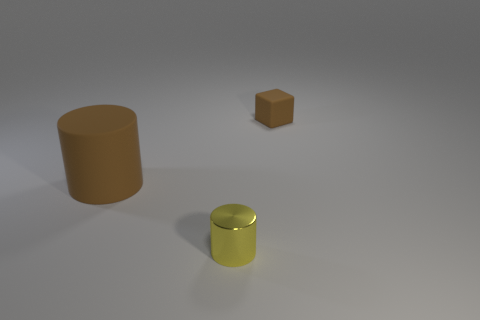Add 1 cyan balls. How many objects exist? 4 Subtract all cylinders. How many objects are left? 1 Subtract all big green metallic blocks. Subtract all rubber cubes. How many objects are left? 2 Add 2 big rubber cylinders. How many big rubber cylinders are left? 3 Add 3 large green metallic cylinders. How many large green metallic cylinders exist? 3 Subtract 1 yellow cylinders. How many objects are left? 2 